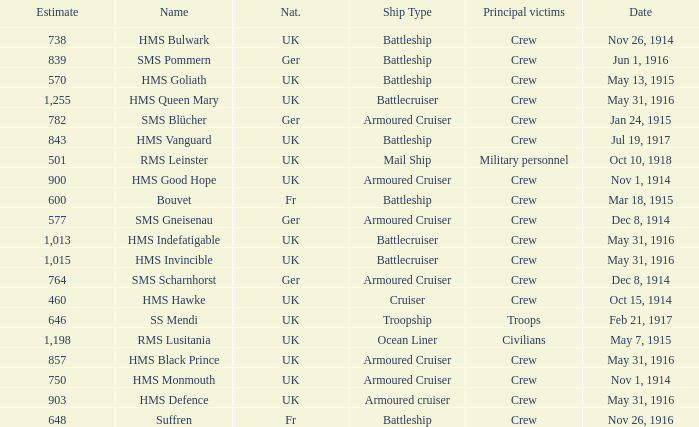What is the nationality of the ship when the principle victims are civilians? UK. 